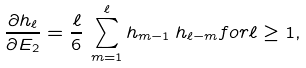<formula> <loc_0><loc_0><loc_500><loc_500>\frac { \partial h _ { \ell } } { \partial E _ { 2 } } = \frac { \ell } { 6 } \, \sum _ { m = 1 } ^ { \ell } h _ { m - 1 } \, h _ { \ell - m } f o r \ell \geq 1 ,</formula> 